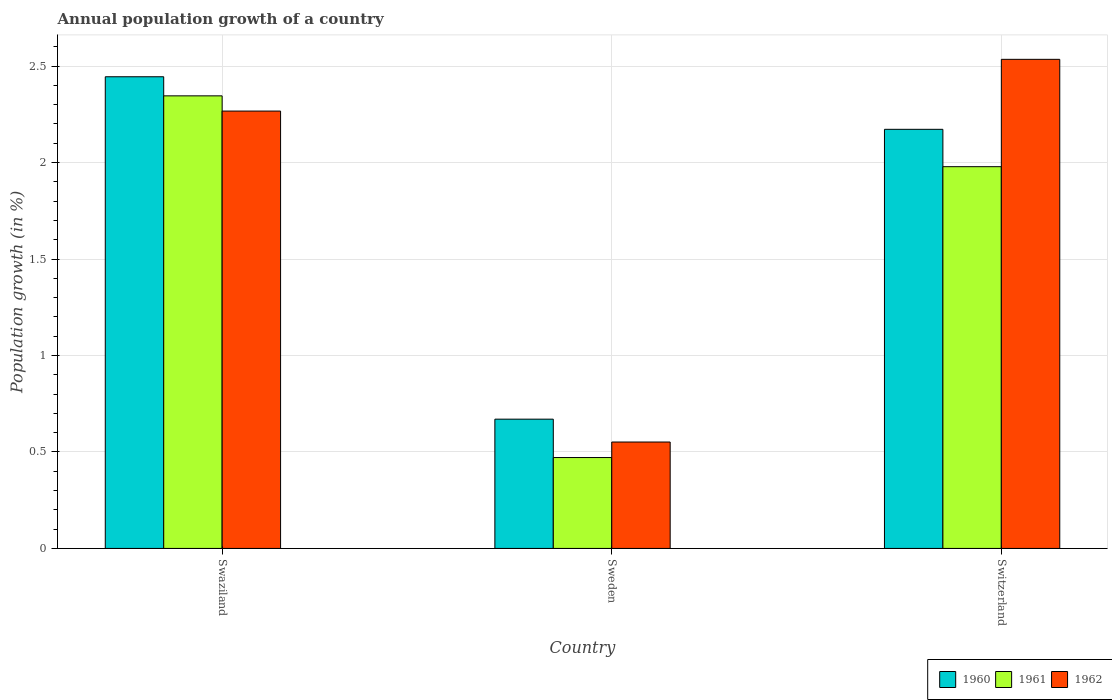Are the number of bars on each tick of the X-axis equal?
Your answer should be compact. Yes. How many bars are there on the 2nd tick from the left?
Give a very brief answer. 3. What is the label of the 2nd group of bars from the left?
Your answer should be compact. Sweden. In how many cases, is the number of bars for a given country not equal to the number of legend labels?
Your answer should be compact. 0. What is the annual population growth in 1961 in Swaziland?
Keep it short and to the point. 2.35. Across all countries, what is the maximum annual population growth in 1961?
Offer a very short reply. 2.35. Across all countries, what is the minimum annual population growth in 1960?
Your answer should be compact. 0.67. In which country was the annual population growth in 1960 maximum?
Ensure brevity in your answer.  Swaziland. In which country was the annual population growth in 1960 minimum?
Your answer should be very brief. Sweden. What is the total annual population growth in 1961 in the graph?
Give a very brief answer. 4.8. What is the difference between the annual population growth in 1961 in Swaziland and that in Switzerland?
Keep it short and to the point. 0.37. What is the difference between the annual population growth in 1960 in Sweden and the annual population growth in 1961 in Swaziland?
Give a very brief answer. -1.68. What is the average annual population growth in 1961 per country?
Your answer should be compact. 1.6. What is the difference between the annual population growth of/in 1962 and annual population growth of/in 1961 in Switzerland?
Keep it short and to the point. 0.56. What is the ratio of the annual population growth in 1962 in Sweden to that in Switzerland?
Provide a short and direct response. 0.22. What is the difference between the highest and the second highest annual population growth in 1961?
Your answer should be compact. -1.51. What is the difference between the highest and the lowest annual population growth in 1962?
Offer a very short reply. 1.98. In how many countries, is the annual population growth in 1962 greater than the average annual population growth in 1962 taken over all countries?
Offer a terse response. 2. Is the sum of the annual population growth in 1962 in Swaziland and Sweden greater than the maximum annual population growth in 1961 across all countries?
Your response must be concise. Yes. What does the 2nd bar from the left in Swaziland represents?
Provide a short and direct response. 1961. Is it the case that in every country, the sum of the annual population growth in 1962 and annual population growth in 1961 is greater than the annual population growth in 1960?
Your answer should be very brief. Yes. Are all the bars in the graph horizontal?
Offer a terse response. No. Does the graph contain any zero values?
Your answer should be very brief. No. Does the graph contain grids?
Provide a short and direct response. Yes. Where does the legend appear in the graph?
Offer a very short reply. Bottom right. What is the title of the graph?
Provide a short and direct response. Annual population growth of a country. What is the label or title of the Y-axis?
Ensure brevity in your answer.  Population growth (in %). What is the Population growth (in %) in 1960 in Swaziland?
Ensure brevity in your answer.  2.44. What is the Population growth (in %) in 1961 in Swaziland?
Provide a succinct answer. 2.35. What is the Population growth (in %) in 1962 in Swaziland?
Your response must be concise. 2.27. What is the Population growth (in %) in 1960 in Sweden?
Provide a succinct answer. 0.67. What is the Population growth (in %) of 1961 in Sweden?
Your answer should be compact. 0.47. What is the Population growth (in %) of 1962 in Sweden?
Make the answer very short. 0.55. What is the Population growth (in %) of 1960 in Switzerland?
Ensure brevity in your answer.  2.17. What is the Population growth (in %) in 1961 in Switzerland?
Give a very brief answer. 1.98. What is the Population growth (in %) in 1962 in Switzerland?
Your answer should be compact. 2.54. Across all countries, what is the maximum Population growth (in %) of 1960?
Make the answer very short. 2.44. Across all countries, what is the maximum Population growth (in %) in 1961?
Your answer should be compact. 2.35. Across all countries, what is the maximum Population growth (in %) of 1962?
Your answer should be very brief. 2.54. Across all countries, what is the minimum Population growth (in %) of 1960?
Your answer should be compact. 0.67. Across all countries, what is the minimum Population growth (in %) in 1961?
Your response must be concise. 0.47. Across all countries, what is the minimum Population growth (in %) in 1962?
Ensure brevity in your answer.  0.55. What is the total Population growth (in %) of 1960 in the graph?
Provide a succinct answer. 5.29. What is the total Population growth (in %) of 1961 in the graph?
Offer a terse response. 4.8. What is the total Population growth (in %) of 1962 in the graph?
Keep it short and to the point. 5.35. What is the difference between the Population growth (in %) of 1960 in Swaziland and that in Sweden?
Your response must be concise. 1.77. What is the difference between the Population growth (in %) of 1961 in Swaziland and that in Sweden?
Give a very brief answer. 1.87. What is the difference between the Population growth (in %) in 1962 in Swaziland and that in Sweden?
Provide a succinct answer. 1.72. What is the difference between the Population growth (in %) in 1960 in Swaziland and that in Switzerland?
Your answer should be very brief. 0.27. What is the difference between the Population growth (in %) in 1961 in Swaziland and that in Switzerland?
Your answer should be compact. 0.37. What is the difference between the Population growth (in %) in 1962 in Swaziland and that in Switzerland?
Offer a very short reply. -0.27. What is the difference between the Population growth (in %) in 1960 in Sweden and that in Switzerland?
Your answer should be very brief. -1.5. What is the difference between the Population growth (in %) of 1961 in Sweden and that in Switzerland?
Offer a very short reply. -1.51. What is the difference between the Population growth (in %) in 1962 in Sweden and that in Switzerland?
Make the answer very short. -1.98. What is the difference between the Population growth (in %) of 1960 in Swaziland and the Population growth (in %) of 1961 in Sweden?
Your response must be concise. 1.97. What is the difference between the Population growth (in %) of 1960 in Swaziland and the Population growth (in %) of 1962 in Sweden?
Give a very brief answer. 1.89. What is the difference between the Population growth (in %) in 1961 in Swaziland and the Population growth (in %) in 1962 in Sweden?
Keep it short and to the point. 1.79. What is the difference between the Population growth (in %) in 1960 in Swaziland and the Population growth (in %) in 1961 in Switzerland?
Your answer should be very brief. 0.47. What is the difference between the Population growth (in %) in 1960 in Swaziland and the Population growth (in %) in 1962 in Switzerland?
Provide a succinct answer. -0.09. What is the difference between the Population growth (in %) in 1961 in Swaziland and the Population growth (in %) in 1962 in Switzerland?
Make the answer very short. -0.19. What is the difference between the Population growth (in %) of 1960 in Sweden and the Population growth (in %) of 1961 in Switzerland?
Offer a very short reply. -1.31. What is the difference between the Population growth (in %) in 1960 in Sweden and the Population growth (in %) in 1962 in Switzerland?
Your answer should be compact. -1.86. What is the difference between the Population growth (in %) of 1961 in Sweden and the Population growth (in %) of 1962 in Switzerland?
Provide a short and direct response. -2.06. What is the average Population growth (in %) of 1960 per country?
Your answer should be very brief. 1.76. What is the average Population growth (in %) of 1961 per country?
Your answer should be compact. 1.6. What is the average Population growth (in %) in 1962 per country?
Your answer should be very brief. 1.78. What is the difference between the Population growth (in %) in 1960 and Population growth (in %) in 1961 in Swaziland?
Provide a succinct answer. 0.1. What is the difference between the Population growth (in %) in 1960 and Population growth (in %) in 1962 in Swaziland?
Provide a succinct answer. 0.18. What is the difference between the Population growth (in %) in 1961 and Population growth (in %) in 1962 in Swaziland?
Provide a succinct answer. 0.08. What is the difference between the Population growth (in %) in 1960 and Population growth (in %) in 1961 in Sweden?
Provide a short and direct response. 0.2. What is the difference between the Population growth (in %) in 1960 and Population growth (in %) in 1962 in Sweden?
Provide a short and direct response. 0.12. What is the difference between the Population growth (in %) in 1961 and Population growth (in %) in 1962 in Sweden?
Provide a short and direct response. -0.08. What is the difference between the Population growth (in %) of 1960 and Population growth (in %) of 1961 in Switzerland?
Give a very brief answer. 0.19. What is the difference between the Population growth (in %) of 1960 and Population growth (in %) of 1962 in Switzerland?
Your response must be concise. -0.36. What is the difference between the Population growth (in %) of 1961 and Population growth (in %) of 1962 in Switzerland?
Your answer should be very brief. -0.56. What is the ratio of the Population growth (in %) of 1960 in Swaziland to that in Sweden?
Provide a short and direct response. 3.65. What is the ratio of the Population growth (in %) in 1961 in Swaziland to that in Sweden?
Make the answer very short. 4.98. What is the ratio of the Population growth (in %) in 1962 in Swaziland to that in Sweden?
Provide a short and direct response. 4.11. What is the ratio of the Population growth (in %) in 1960 in Swaziland to that in Switzerland?
Your response must be concise. 1.13. What is the ratio of the Population growth (in %) of 1961 in Swaziland to that in Switzerland?
Provide a short and direct response. 1.19. What is the ratio of the Population growth (in %) in 1962 in Swaziland to that in Switzerland?
Provide a succinct answer. 0.89. What is the ratio of the Population growth (in %) of 1960 in Sweden to that in Switzerland?
Give a very brief answer. 0.31. What is the ratio of the Population growth (in %) in 1961 in Sweden to that in Switzerland?
Provide a succinct answer. 0.24. What is the ratio of the Population growth (in %) in 1962 in Sweden to that in Switzerland?
Offer a terse response. 0.22. What is the difference between the highest and the second highest Population growth (in %) of 1960?
Offer a very short reply. 0.27. What is the difference between the highest and the second highest Population growth (in %) in 1961?
Keep it short and to the point. 0.37. What is the difference between the highest and the second highest Population growth (in %) in 1962?
Your response must be concise. 0.27. What is the difference between the highest and the lowest Population growth (in %) in 1960?
Provide a short and direct response. 1.77. What is the difference between the highest and the lowest Population growth (in %) of 1961?
Ensure brevity in your answer.  1.87. What is the difference between the highest and the lowest Population growth (in %) in 1962?
Provide a succinct answer. 1.98. 